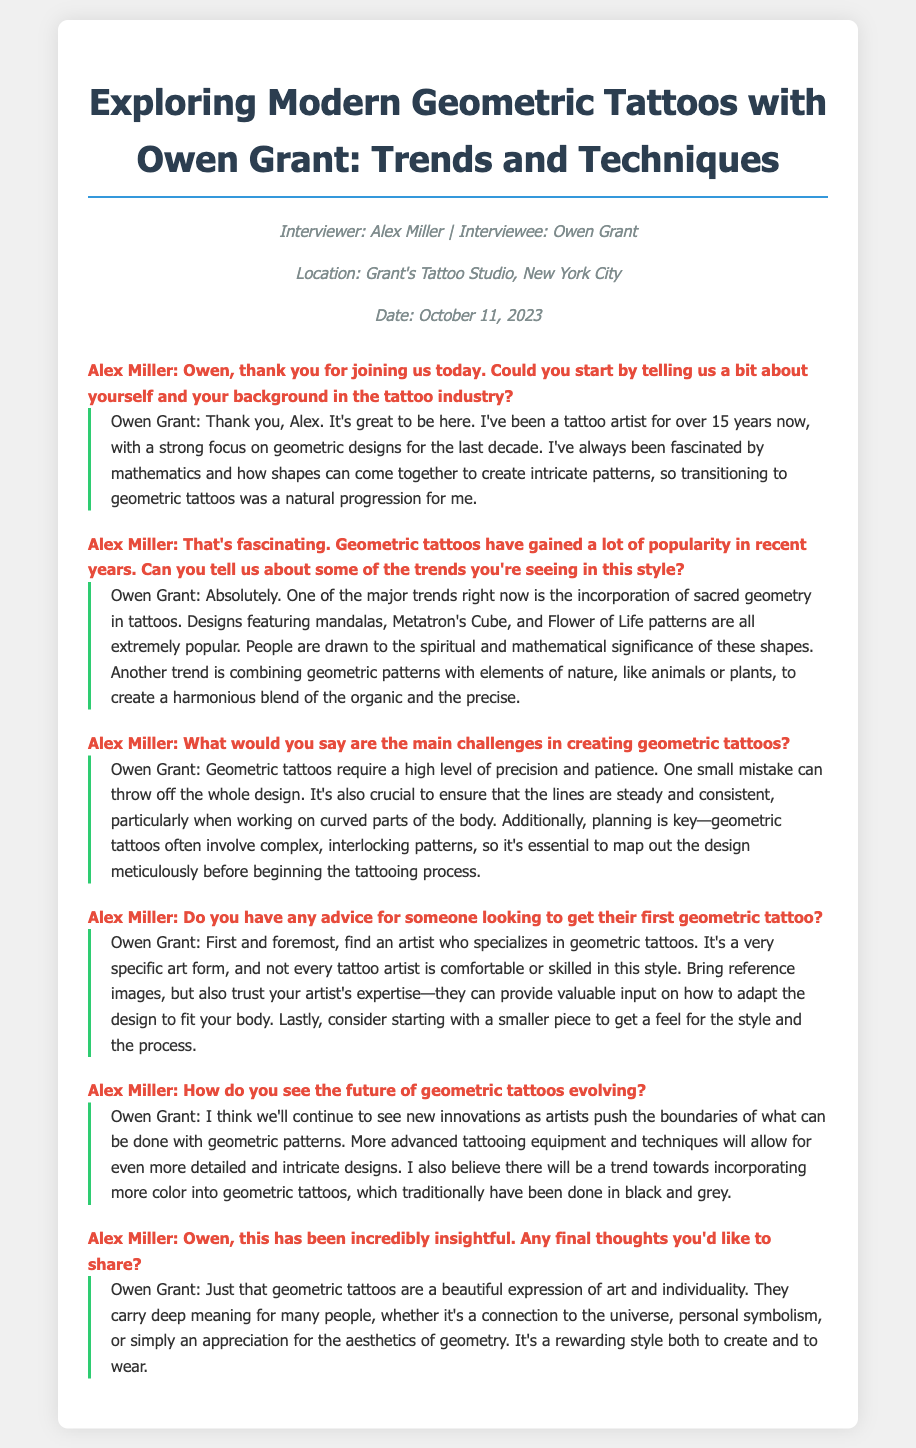What is the name of the interviewee? The interviewee is Owen Grant, a renowned tattoo artist.
Answer: Owen Grant What is the location of the interview? The interview took place at Grant's Tattoo Studio in New York City.
Answer: Grant's Tattoo Studio, New York City How many years has Owen Grant been a tattoo artist? Owen Grant has over 15 years of experience in the tattoo industry.
Answer: 15 years What is a major trend in geometric tattoos mentioned by Owen? Owen mentions the incorporation of sacred geometry as a major trend in geometric tattoos.
Answer: Sacred geometry What advice does Owen give for a first geometric tattoo? Owen advises to find an artist who specializes in geometric tattoos for the first piece.
Answer: Find a specialist What does Owen believe will trend in the future of geometric tattoos? Owen believes there will be a trend towards incorporating more color into geometric tattoos.
Answer: More color What is the date of the interview? The interview was conducted on October 11, 2023.
Answer: October 11, 2023 What is the main challenge in creating geometric tattoos, according to Owen? A main challenge is maintaining precision and patience in the design execution.
Answer: Precision and patience What is the title of the document? The title of the document provides insights into modern geometric tattoos with Owen Grant.
Answer: Exploring Modern Geometric Tattoos with Owen Grant: Trends and Techniques 